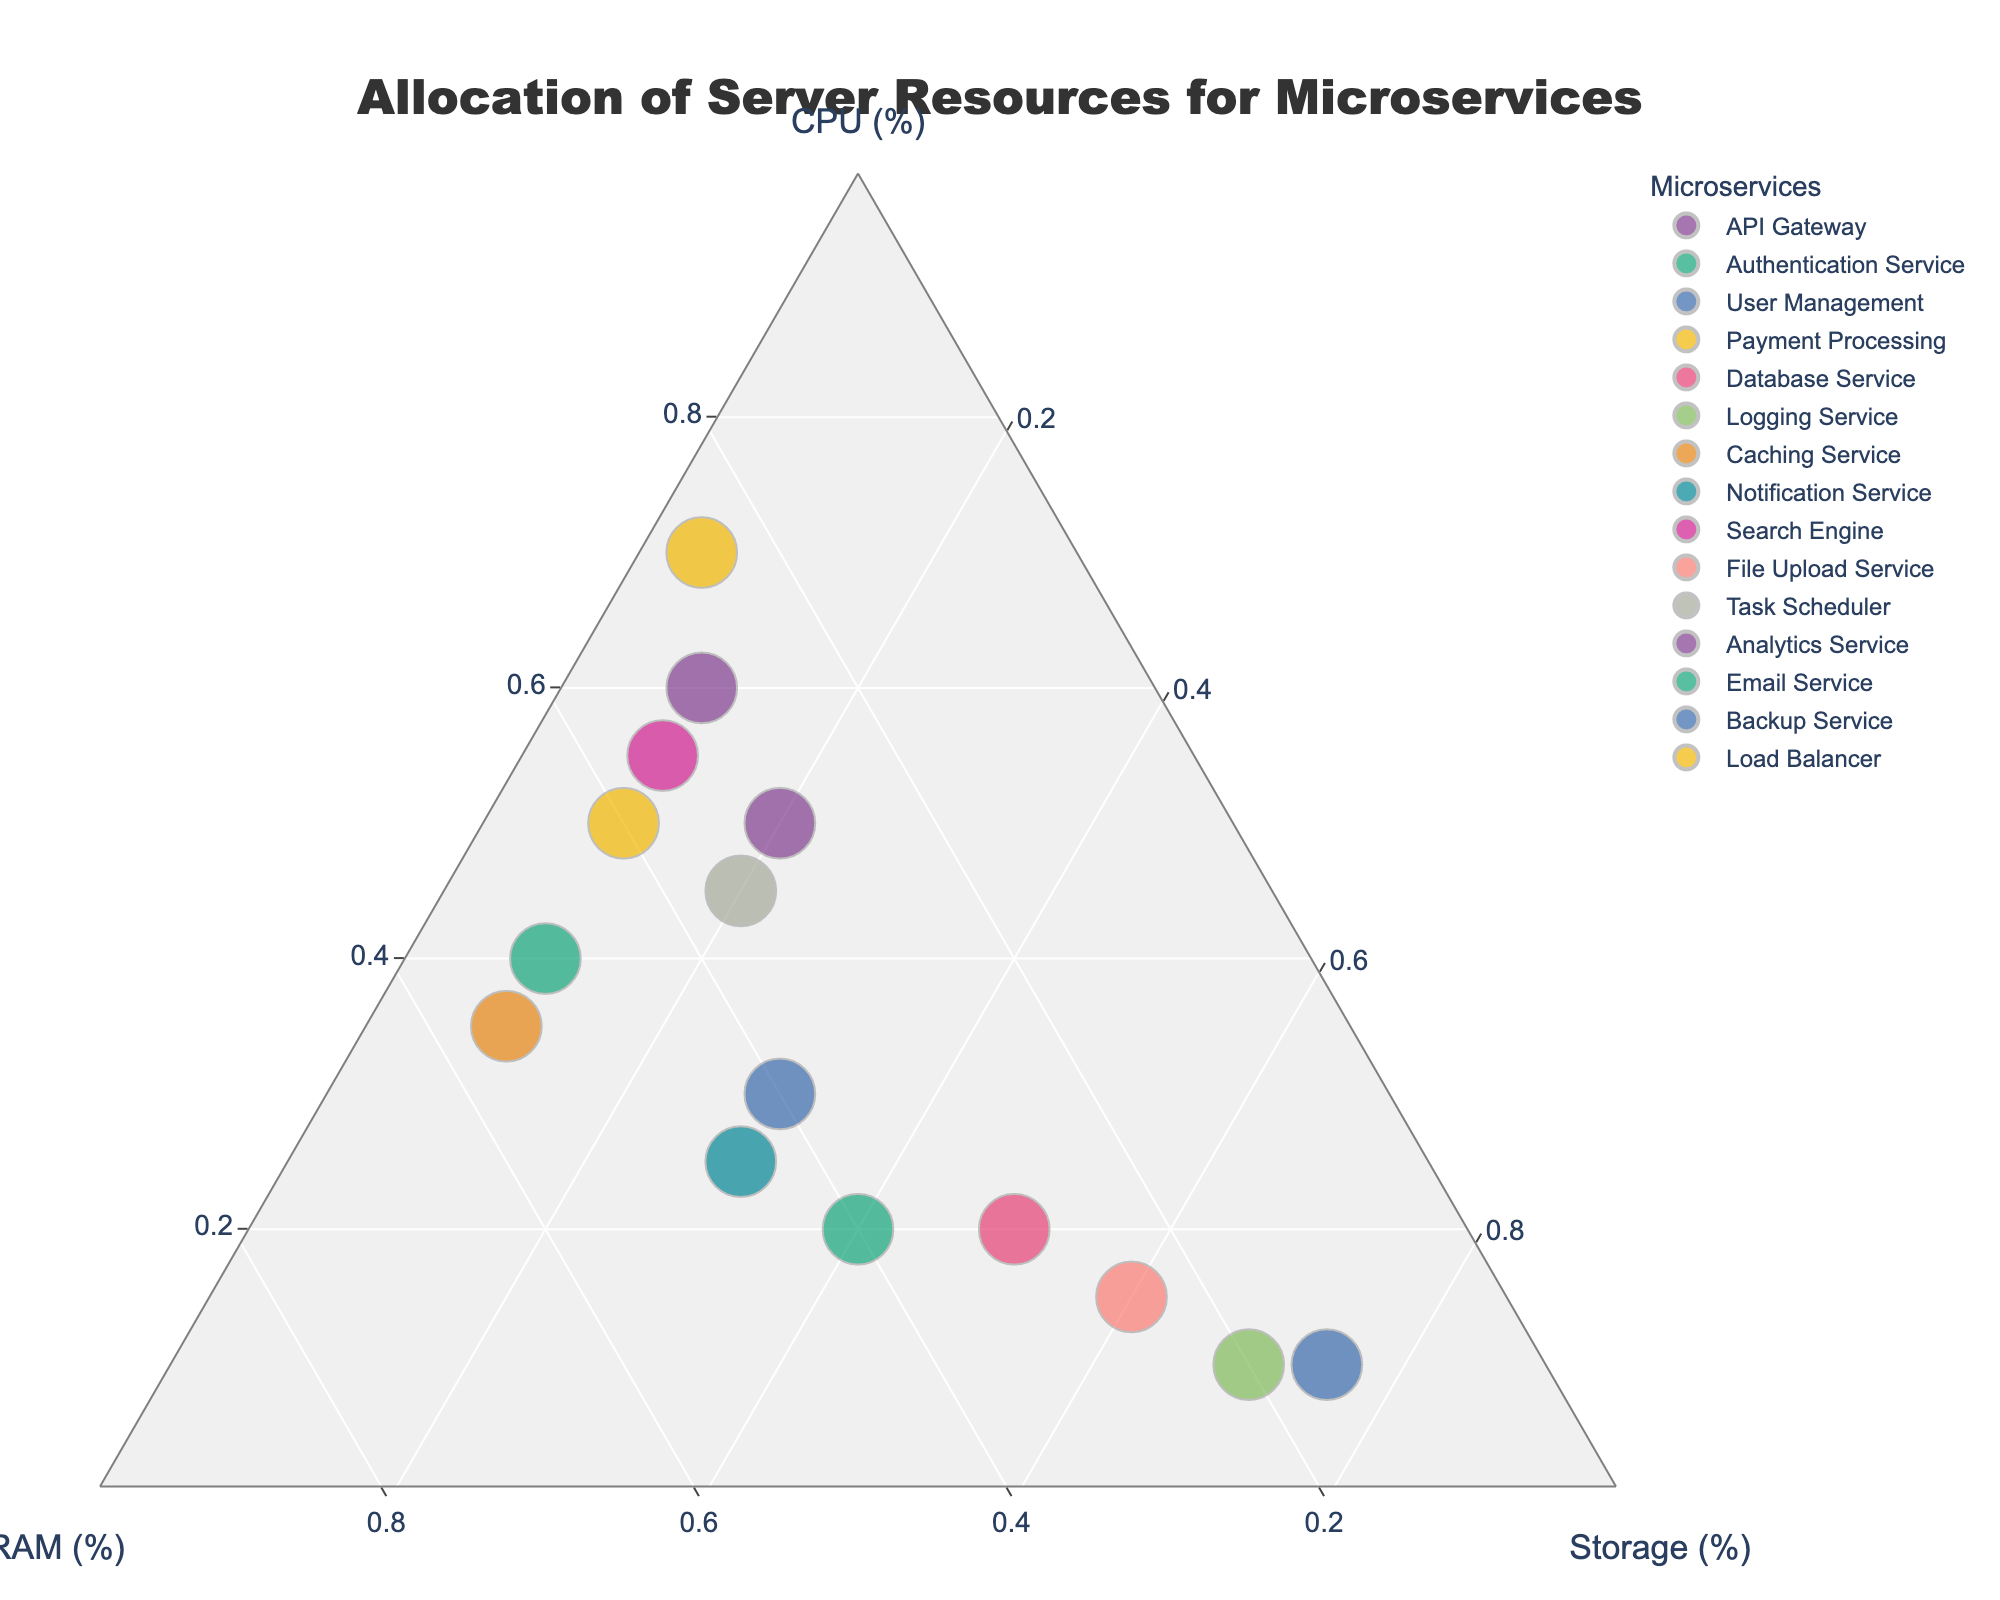What is the title of the plot? The title is prominently displayed at the top center of the plot. It summarizes the main theme of the figure.
Answer: Allocation of Server Resources for Microservices Which microservice uses the highest percentage of storage? By looking at the top corner of the triangle labeled for storage, the point farthest from the opposing axis is the microservice with the highest storage percentage.
Answer: Backup Service How many microservices allocate more than 50% of their resources to CPU? Points near the CPU axis (on the left side) with values over 50% can be counted.
Answer: 4 Which microservice has the smallest total allocation of resources, and what is it? The size of the points indicates the sum of resources. The smallest point shown represents the microservice with the least resource allocation.
Answer: Logging Service What percentage of resources does the Authentication Service allocate to RAM? Hovering over the Authentication Service point will show its specific value for RAM.
Answer: 50% Which microservice allocates equally between CPU and RAM, and what is their allocation percentage for storage? Points aligned between the CPU and RAM axes, indicating equal resource allocation to these two components, should be checked for their storage values. The Authentication Service (40% CPU, 50% RAM) and Caching Service (35% CPU, 55% RAM) are almost equal. Storage allocation can be determined by subtracting their CPU and RAM allocations from 100%.
Answer: Authentication Service: 10%, Caching Service: 10% Among the microservices that allocate less than 20% of resources to RAM, which one allocates the highest percentage to storage? Look for points concentrated near the lower part of the RAM axis (right side) with values < 20%, then identify the one with the highest storage allocation.
Answer: Backup Service Calculate the total storage allocation percentage for Caching Service, Logging Service, and File Upload Service combined. Adding the storage percentages for these services (Caching Service: 10%, Logging Service: 70%, File Upload Service: 60%) gives the combined total.
Answer: 140% Which two microservices allocate approximately the same percentages to CPU and storage? Identify points on or near the line connecting the CPU and Storage axes, indicating approximately equal resource allocation to these components. Then, cross-reference these points to ensure their similar values. API Gateway (60% CPU, 10% storage) and Search Engine (55% CPU, 10% Storage) allocate approximately the same percentages of resources to CPU and storage.
Answer: API Gateway & Search Engine Compare the total resource allocation (CPU, RAM, Storage) between the Email Service and Task Scheduler. Which one has a higher total allocation? By comparing the point sizes that represent the sum of resources, the microservice with the larger point has a higher total resource allocation.
Answer: Task Scheduler 